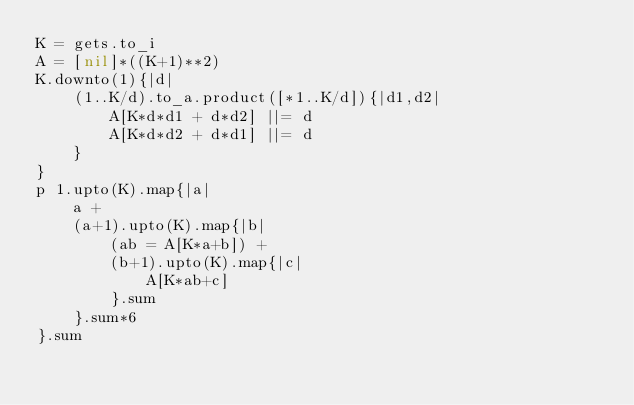<code> <loc_0><loc_0><loc_500><loc_500><_Ruby_>K = gets.to_i
A = [nil]*((K+1)**2)
K.downto(1){|d|
	(1..K/d).to_a.product([*1..K/d]){|d1,d2|
		A[K*d*d1 + d*d2] ||= d
		A[K*d*d2 + d*d1] ||= d
	}
}
p 1.upto(K).map{|a|
	a +
	(a+1).upto(K).map{|b|
		(ab = A[K*a+b]) +
		(b+1).upto(K).map{|c|
			A[K*ab+c]
		}.sum
	}.sum*6
}.sum
</code> 